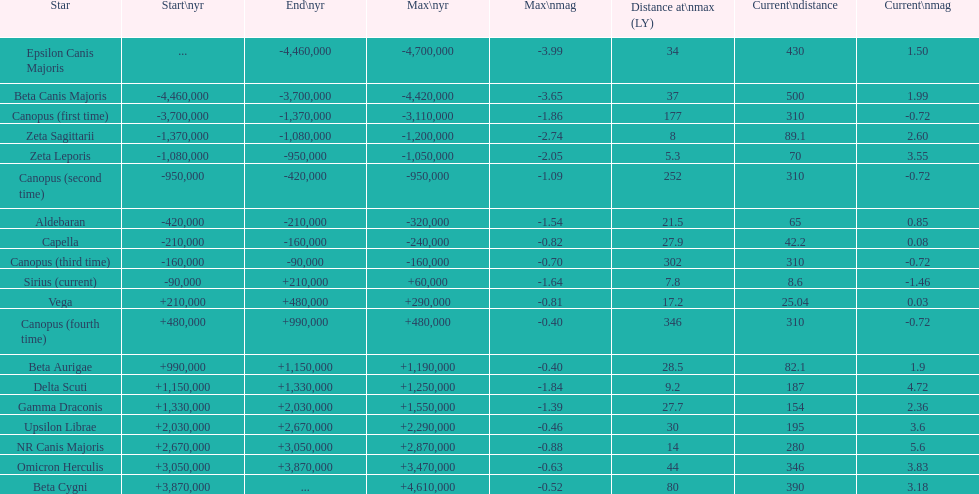Could you parse the entire table as a dict? {'header': ['Star', 'Start\\nyr', 'End\\nyr', 'Max\\nyr', 'Max\\nmag', 'Distance at\\nmax (LY)', 'Current\\ndistance', 'Current\\nmag'], 'rows': [['Epsilon Canis Majoris', '...', '-4,460,000', '-4,700,000', '-3.99', '34', '430', '1.50'], ['Beta Canis Majoris', '-4,460,000', '-3,700,000', '-4,420,000', '-3.65', '37', '500', '1.99'], ['Canopus (first time)', '-3,700,000', '-1,370,000', '-3,110,000', '-1.86', '177', '310', '-0.72'], ['Zeta Sagittarii', '-1,370,000', '-1,080,000', '-1,200,000', '-2.74', '8', '89.1', '2.60'], ['Zeta Leporis', '-1,080,000', '-950,000', '-1,050,000', '-2.05', '5.3', '70', '3.55'], ['Canopus (second time)', '-950,000', '-420,000', '-950,000', '-1.09', '252', '310', '-0.72'], ['Aldebaran', '-420,000', '-210,000', '-320,000', '-1.54', '21.5', '65', '0.85'], ['Capella', '-210,000', '-160,000', '-240,000', '-0.82', '27.9', '42.2', '0.08'], ['Canopus (third time)', '-160,000', '-90,000', '-160,000', '-0.70', '302', '310', '-0.72'], ['Sirius (current)', '-90,000', '+210,000', '+60,000', '-1.64', '7.8', '8.6', '-1.46'], ['Vega', '+210,000', '+480,000', '+290,000', '-0.81', '17.2', '25.04', '0.03'], ['Canopus (fourth time)', '+480,000', '+990,000', '+480,000', '-0.40', '346', '310', '-0.72'], ['Beta Aurigae', '+990,000', '+1,150,000', '+1,190,000', '-0.40', '28.5', '82.1', '1.9'], ['Delta Scuti', '+1,150,000', '+1,330,000', '+1,250,000', '-1.84', '9.2', '187', '4.72'], ['Gamma Draconis', '+1,330,000', '+2,030,000', '+1,550,000', '-1.39', '27.7', '154', '2.36'], ['Upsilon Librae', '+2,030,000', '+2,670,000', '+2,290,000', '-0.46', '30', '195', '3.6'], ['NR Canis Majoris', '+2,670,000', '+3,050,000', '+2,870,000', '-0.88', '14', '280', '5.6'], ['Omicron Herculis', '+3,050,000', '+3,870,000', '+3,470,000', '-0.63', '44', '346', '3.83'], ['Beta Cygni', '+3,870,000', '...', '+4,610,000', '-0.52', '80', '390', '3.18']]} How many stars have a current magnitude of at least 1.0? 11. 